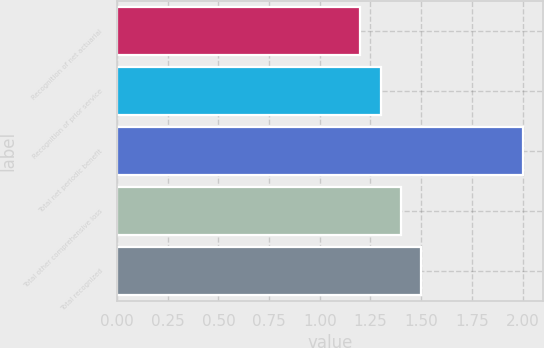Convert chart to OTSL. <chart><loc_0><loc_0><loc_500><loc_500><bar_chart><fcel>Recognition of net actuarial<fcel>Recognition of prior service<fcel>Total net periodic benefit<fcel>Total other comprehensive loss<fcel>Total recognized<nl><fcel>1.2<fcel>1.3<fcel>2<fcel>1.4<fcel>1.5<nl></chart> 